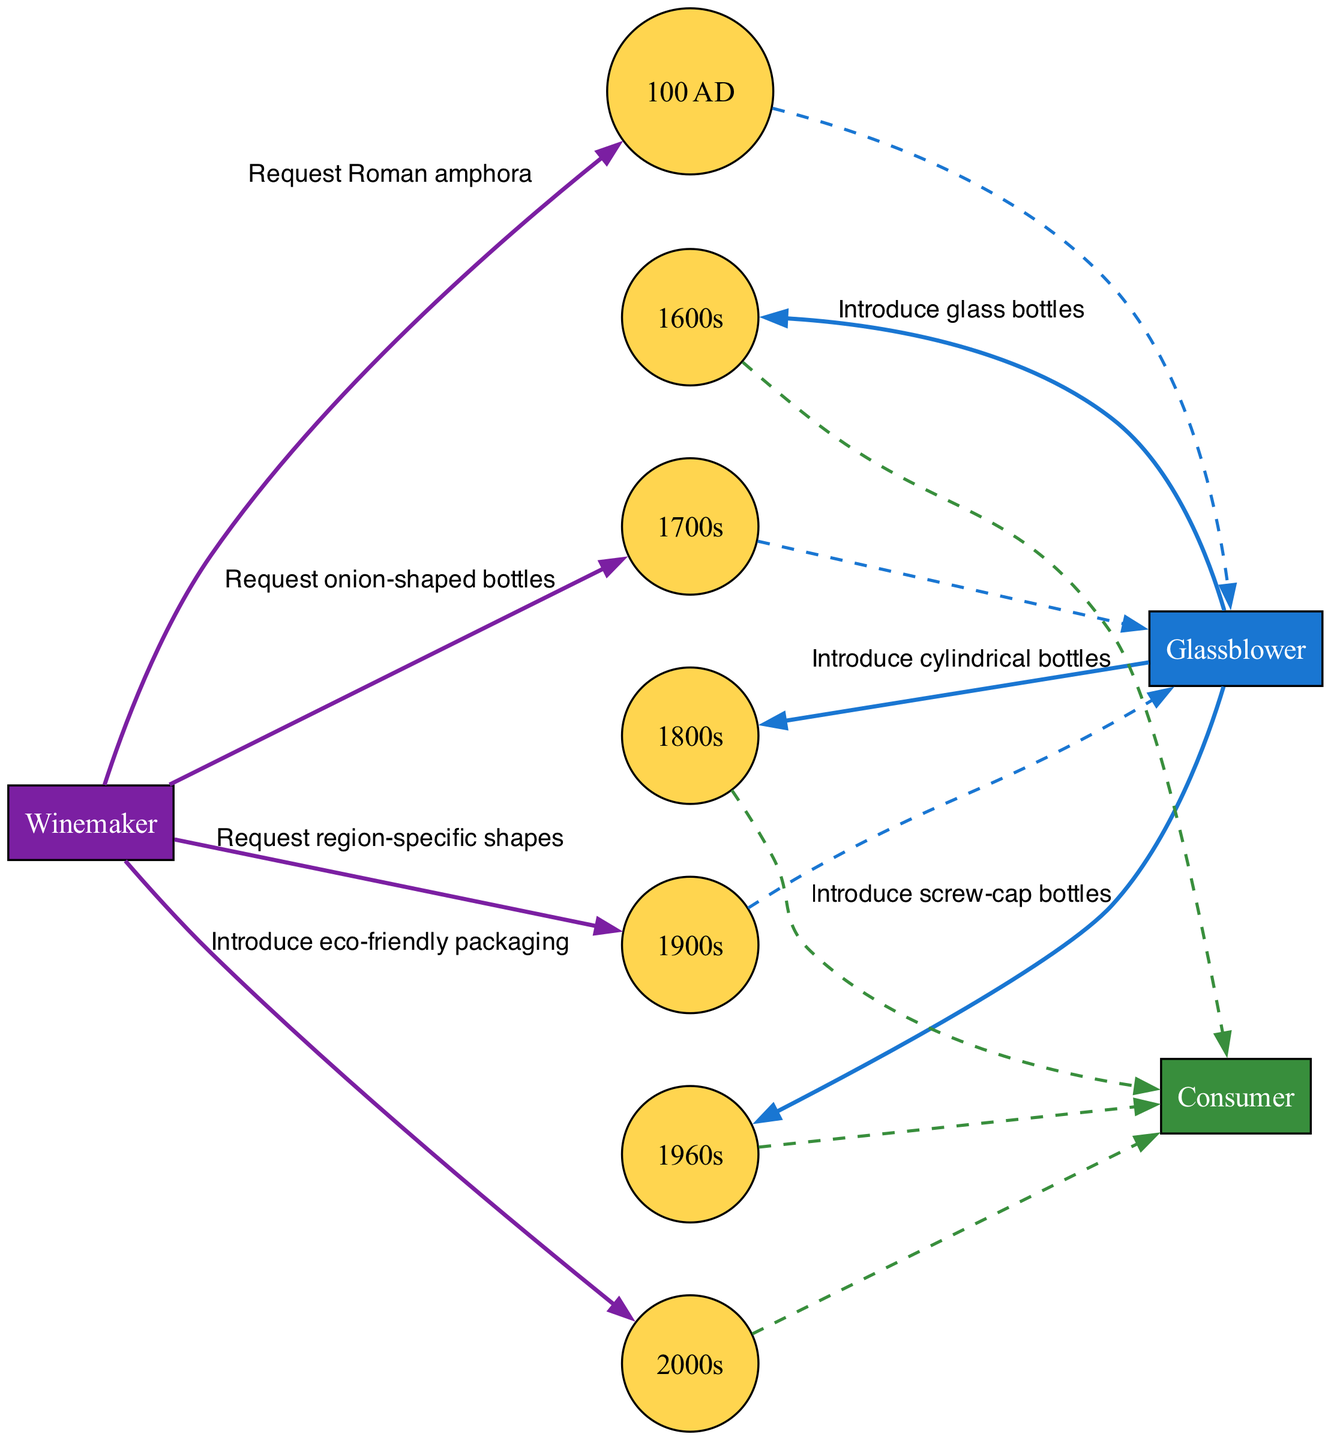What is the first major change in wine bottle design? The first major change mentioned in the diagram is the request for Roman amphora, which occurred in 100 AD. This marks the beginning of the evolution of wine bottle design.
Answer: Roman amphora (100 AD) How many major changes are presented in the diagram? By counting the sequence of messages in the diagram, we find a total of 7 distinct changes in wine bottle design highlighted.
Answer: 7 Who introduced glass bottles? The diagram indicates that the Glassblower was responsible for introducing glass bottles in the 1600s.
Answer: Glassblower What kind of shape did winemakers request in the 1700s? According to the sequence, winemakers requested onion-shaped bottles during the 1700s, showing a specific design preference at that time.
Answer: onion-shaped bottles What decade did screw-cap bottles appear? The introduction of screw-cap bottles occurred in the 1960s, as stated in the diagram where the sequence is detailed.
Answer: 1960s What is the relationship between Glassblower and Consumer in the 1600s? The relationship described in the diagram shows that the Glassblower introduced glass bottles to the Consumer in the 1600s, indicating a direct connection in the supply chain.
Answer: Introduce glass bottles Which actor initiates the request for region-specific shapes? The request for region-specific shapes was initiated by the Winemaker in the 1900s, as shown in the sequence flow of the diagram.
Answer: Winemaker What is the ultimate product introduced in the 2000s? In the 2000s, the ultimate product introduced by the Winemaker to the Consumer was eco-friendly packaging, as depicted in the final sequence of the diagram.
Answer: eco-friendly packaging 